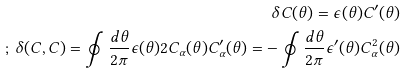Convert formula to latex. <formula><loc_0><loc_0><loc_500><loc_500>\delta C ( \theta ) = \epsilon ( \theta ) C ^ { \prime } ( \theta ) \\ ; \, \delta ( C , C ) = \oint \frac { d \theta } { 2 \pi } \epsilon ( \theta ) 2 C _ { \alpha } ( \theta ) C ^ { \prime } _ { \alpha } ( \theta ) = - \oint \frac { d \theta } { 2 \pi } \epsilon ^ { \prime } ( \theta ) C _ { \alpha } ^ { 2 } ( \theta )</formula> 